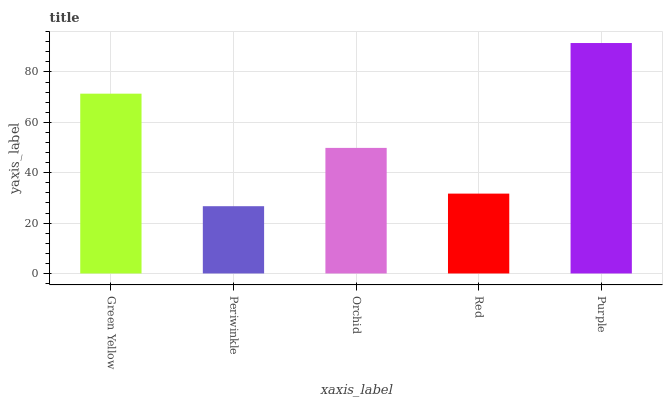Is Orchid the minimum?
Answer yes or no. No. Is Orchid the maximum?
Answer yes or no. No. Is Orchid greater than Periwinkle?
Answer yes or no. Yes. Is Periwinkle less than Orchid?
Answer yes or no. Yes. Is Periwinkle greater than Orchid?
Answer yes or no. No. Is Orchid less than Periwinkle?
Answer yes or no. No. Is Orchid the high median?
Answer yes or no. Yes. Is Orchid the low median?
Answer yes or no. Yes. Is Periwinkle the high median?
Answer yes or no. No. Is Purple the low median?
Answer yes or no. No. 